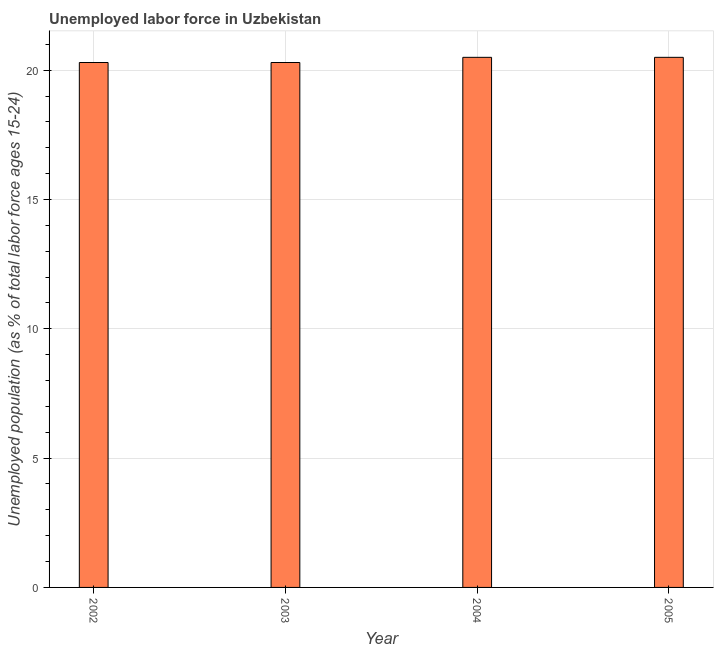Does the graph contain any zero values?
Ensure brevity in your answer.  No. What is the title of the graph?
Offer a very short reply. Unemployed labor force in Uzbekistan. What is the label or title of the Y-axis?
Provide a short and direct response. Unemployed population (as % of total labor force ages 15-24). Across all years, what is the minimum total unemployed youth population?
Make the answer very short. 20.3. In which year was the total unemployed youth population minimum?
Ensure brevity in your answer.  2002. What is the sum of the total unemployed youth population?
Offer a terse response. 81.6. What is the average total unemployed youth population per year?
Give a very brief answer. 20.4. What is the median total unemployed youth population?
Offer a terse response. 20.4. In how many years, is the total unemployed youth population greater than 19 %?
Keep it short and to the point. 4. Do a majority of the years between 2003 and 2004 (inclusive) have total unemployed youth population greater than 20 %?
Your answer should be very brief. Yes. What is the ratio of the total unemployed youth population in 2002 to that in 2005?
Keep it short and to the point. 0.99. Is the total unemployed youth population in 2003 less than that in 2004?
Offer a terse response. Yes. What is the difference between the highest and the second highest total unemployed youth population?
Keep it short and to the point. 0. Is the sum of the total unemployed youth population in 2003 and 2004 greater than the maximum total unemployed youth population across all years?
Make the answer very short. Yes. What is the difference between the highest and the lowest total unemployed youth population?
Keep it short and to the point. 0.2. In how many years, is the total unemployed youth population greater than the average total unemployed youth population taken over all years?
Keep it short and to the point. 2. How many bars are there?
Your answer should be very brief. 4. Are all the bars in the graph horizontal?
Give a very brief answer. No. How many years are there in the graph?
Provide a succinct answer. 4. Are the values on the major ticks of Y-axis written in scientific E-notation?
Your response must be concise. No. What is the Unemployed population (as % of total labor force ages 15-24) in 2002?
Your answer should be very brief. 20.3. What is the Unemployed population (as % of total labor force ages 15-24) in 2003?
Ensure brevity in your answer.  20.3. What is the difference between the Unemployed population (as % of total labor force ages 15-24) in 2002 and 2004?
Your response must be concise. -0.2. What is the difference between the Unemployed population (as % of total labor force ages 15-24) in 2003 and 2005?
Offer a terse response. -0.2. What is the ratio of the Unemployed population (as % of total labor force ages 15-24) in 2003 to that in 2004?
Make the answer very short. 0.99. What is the ratio of the Unemployed population (as % of total labor force ages 15-24) in 2003 to that in 2005?
Provide a short and direct response. 0.99. What is the ratio of the Unemployed population (as % of total labor force ages 15-24) in 2004 to that in 2005?
Keep it short and to the point. 1. 